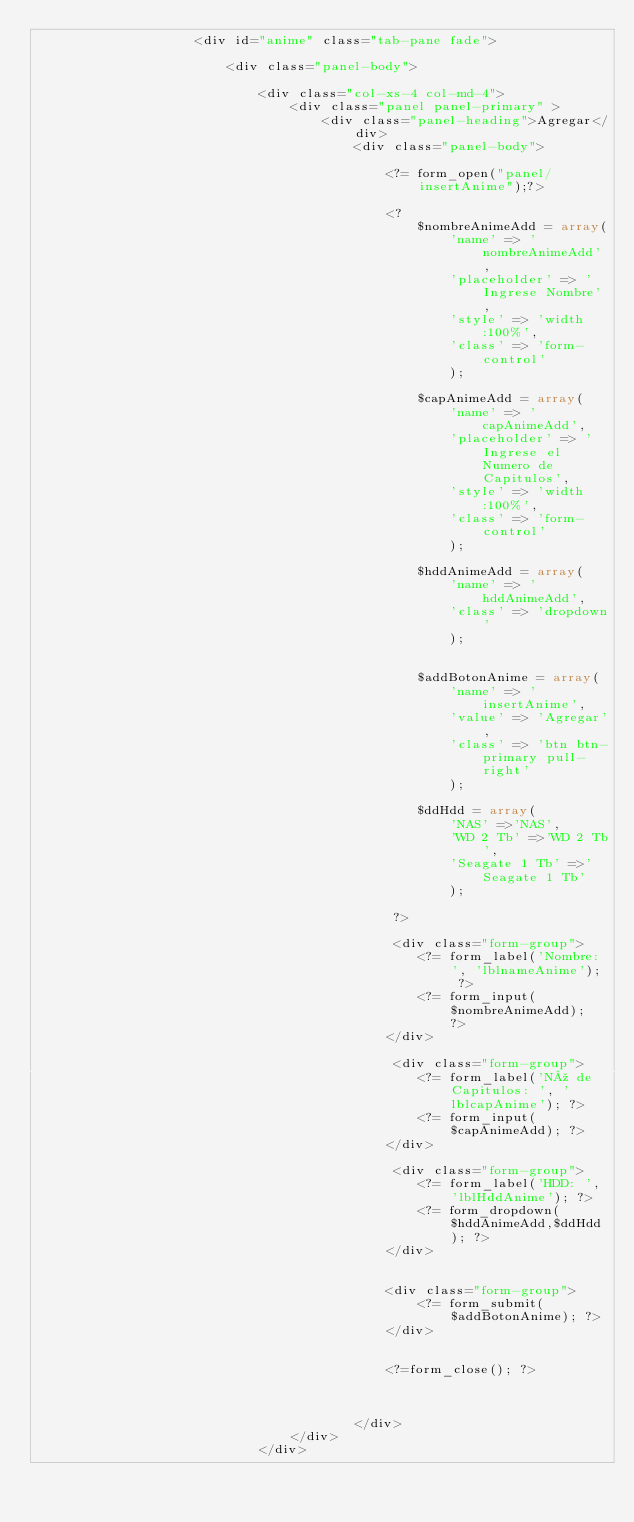Convert code to text. <code><loc_0><loc_0><loc_500><loc_500><_PHP_>					<div id="anime" class="tab-pane fade">

						<div class="panel-body">

			  				<div class="col-xs-4 col-md-4">
							    <div class="panel panel-primary" >
							    	<div class="panel-heading">Agregar</div>
							    		<div class="panel-body">

											<?= form_open("panel/insertAnime");?>

			     					 		<?
			     					 			$nombreAnimeAdd = array(
			     					 				'name' => 'nombreAnimeAdd',
			     					 				'placeholder' => 'Ingrese Nombre',
			     					 				'style' => 'width:100%',
			     					 				'class' => 'form-control'
			     					 				);

			     					 			$capAnimeAdd = array(
			     					 				'name' => 'capAnimeAdd',
			     					 				'placeholder' => 'Ingrese el Numero de Capitulos',
			     					 				'style' => 'width:100%',
			     					 				'class' => 'form-control'
			     					 				);

			     					 			$hddAnimeAdd = array(
			     					 				'name' => 'hddAnimeAdd',
			     					 				'class' => 'dropdown'
			     					 				);


			     					 			$addBotonAnime = array(
			     					 				'name' => 'insertAnime',
			     					 				'value' => 'Agregar',
			     					 				'class' => 'btn btn-primary pull-right'
			     					 				);

			     					 			$ddHdd = array(
			     					 				'NAS' =>'NAS',
			     					 				'WD 2 Tb' =>'WD 2 Tb',
			     					 				'Seagate 1 Tb' =>'Seagate 1 Tb'
			     					 				);

			     					 		 ?>

			     					 		 <div class="form-group">
				     					 		<?= form_label('Nombre: ', 'lblnameAnime'); ?>
				     					 		<?= form_input($nombreAnimeAdd); ?>
				     					 	</div>		

			     					 		 <div class="form-group">
				     					 		<?= form_label('Nº de Capitulos: ', 'lblcapAnime'); ?>
				     					 		<?= form_input($capAnimeAdd); ?>
				     					 	</div>	

			     					 		 <div class="form-group">
				     					 		<?= form_label('HDD: ', 'lblHddAnime'); ?>
				     					 		<?= form_dropdown($hddAnimeAdd,$ddHdd); ?>
				     					 	</div>				   	 	
	     					 

			     					 		<div class="form-group">
			     					 			<?= form_submit($addBotonAnime); ?>
			     					 		</div>


			     					 		<?=form_close(); ?>



							    		</div>			
							    </div>
							</div>
</code> 